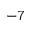<formula> <loc_0><loc_0><loc_500><loc_500>^ { - 7 }</formula> 